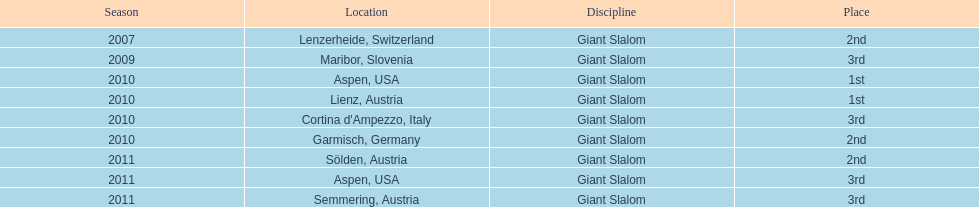What is the total number of her 2nd place finishes on the list? 3. 